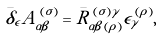<formula> <loc_0><loc_0><loc_500><loc_500>\bar { \delta } _ { \epsilon } A _ { \alpha \beta } ^ { \, ( \sigma ) } = \bar { R } _ { \alpha \beta \, ( \rho ) } ^ { \, ( \sigma ) \gamma } \epsilon _ { \gamma } ^ { \, ( \rho ) } ,</formula> 